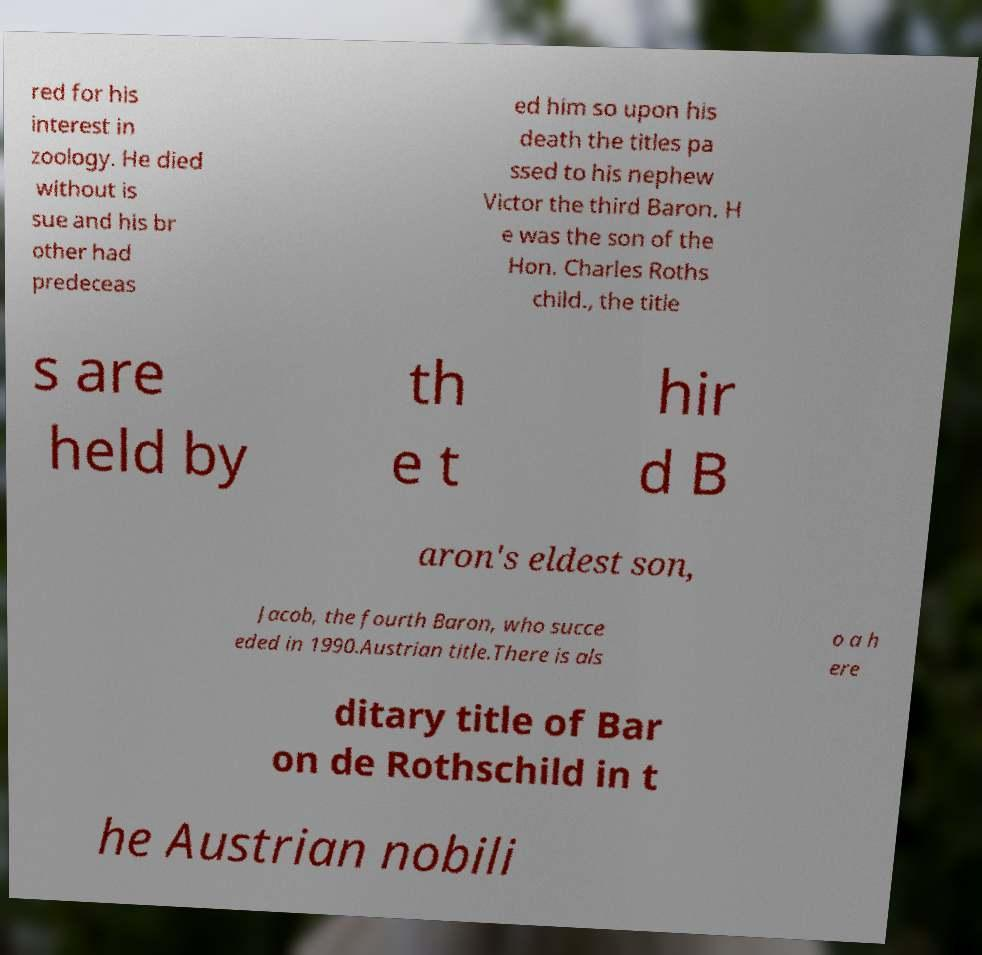Please read and relay the text visible in this image. What does it say? red for his interest in zoology. He died without is sue and his br other had predeceas ed him so upon his death the titles pa ssed to his nephew Victor the third Baron. H e was the son of the Hon. Charles Roths child., the title s are held by th e t hir d B aron's eldest son, Jacob, the fourth Baron, who succe eded in 1990.Austrian title.There is als o a h ere ditary title of Bar on de Rothschild in t he Austrian nobili 